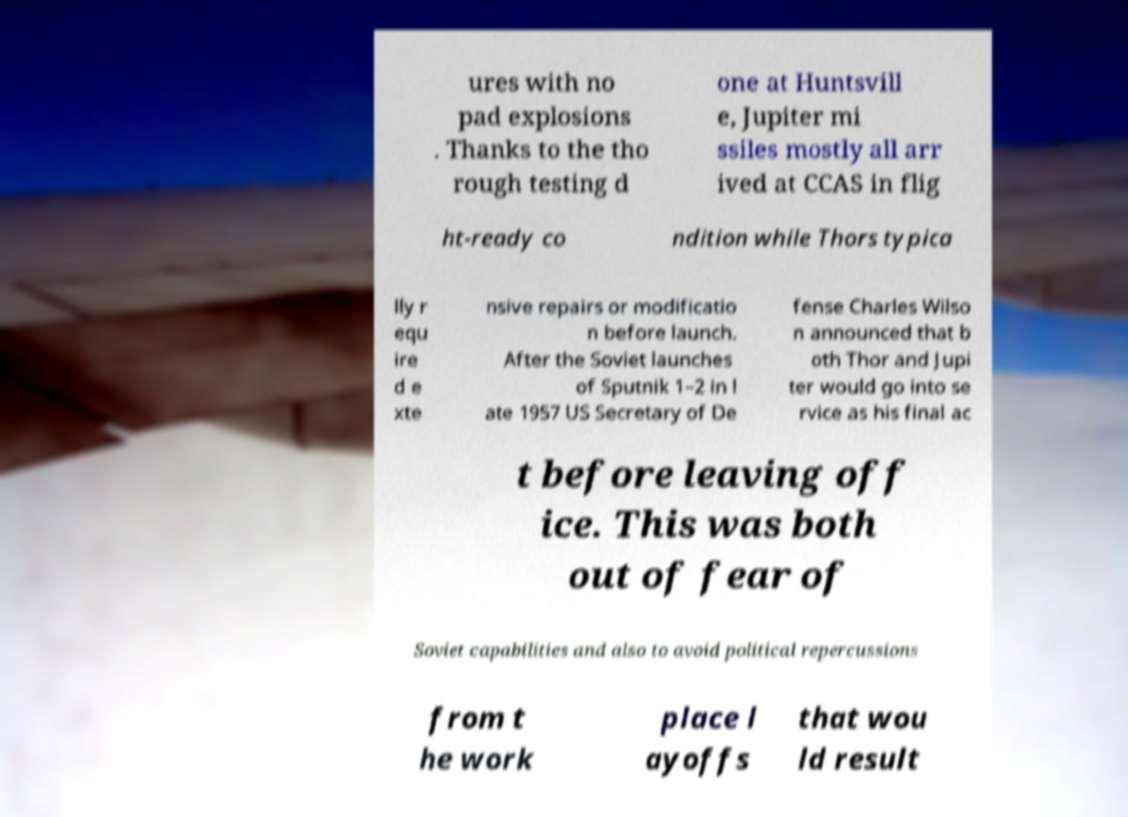Can you read and provide the text displayed in the image?This photo seems to have some interesting text. Can you extract and type it out for me? ures with no pad explosions . Thanks to the tho rough testing d one at Huntsvill e, Jupiter mi ssiles mostly all arr ived at CCAS in flig ht-ready co ndition while Thors typica lly r equ ire d e xte nsive repairs or modificatio n before launch. After the Soviet launches of Sputnik 1–2 in l ate 1957 US Secretary of De fense Charles Wilso n announced that b oth Thor and Jupi ter would go into se rvice as his final ac t before leaving off ice. This was both out of fear of Soviet capabilities and also to avoid political repercussions from t he work place l ayoffs that wou ld result 